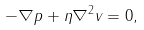Convert formula to latex. <formula><loc_0><loc_0><loc_500><loc_500>- \nabla p + \eta \nabla ^ { 2 } { v } = 0 ,</formula> 